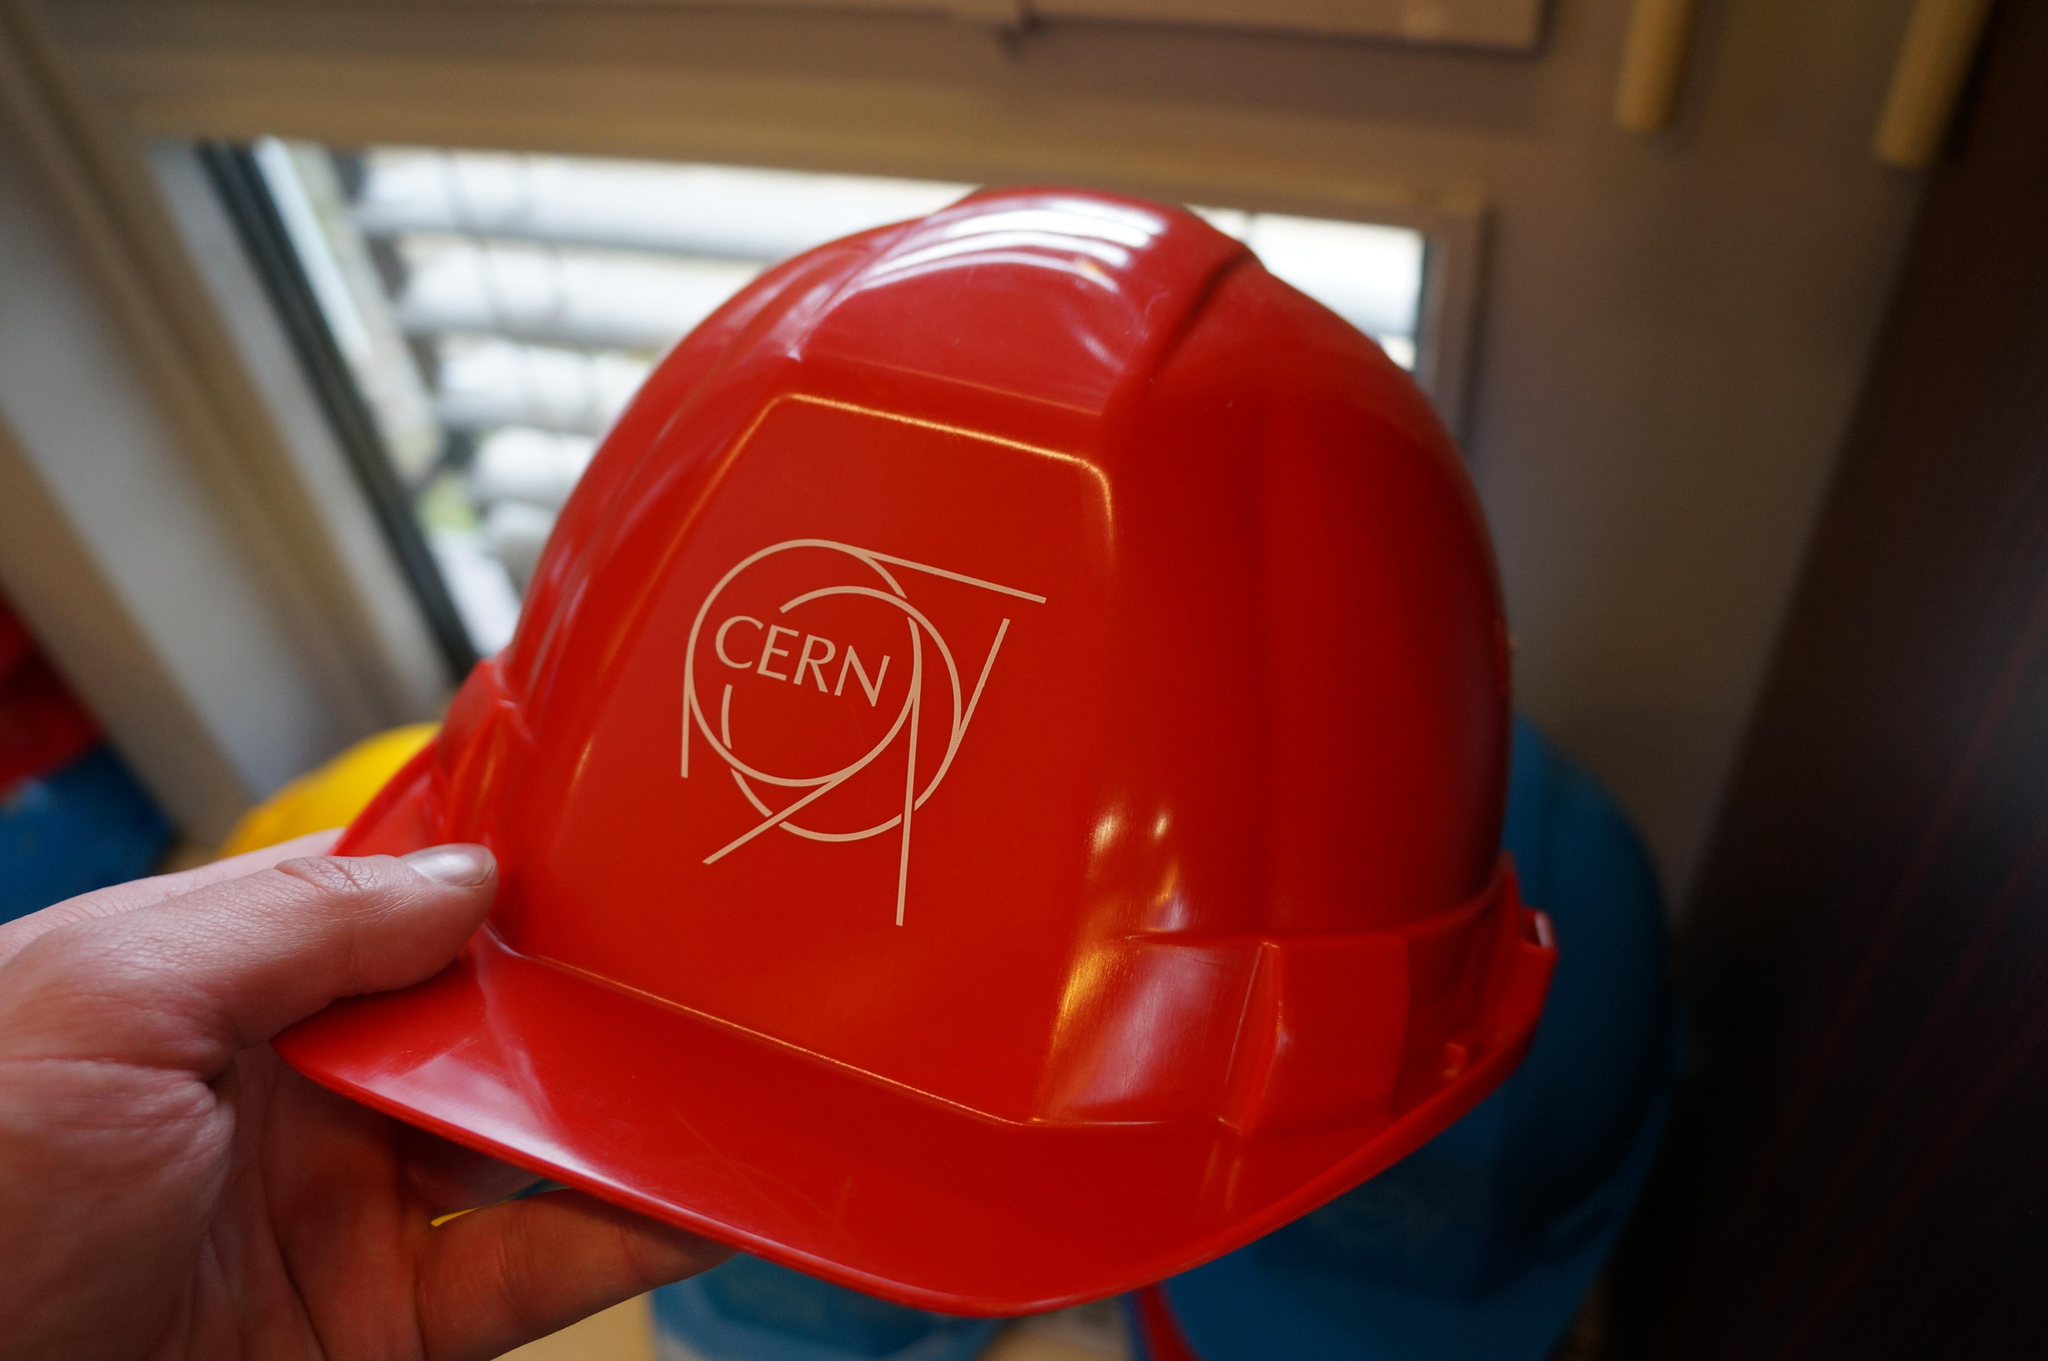What is the main subject of the image? There is a person in the image. What is the person holding in the image? The person is holding a red color hat. Can you describe the background of the image? The background of the image is blurred. What type of voice can be heard coming from the person in the image? There is no indication of any sound or voice in the image, as it is a still photograph. What type of test is being conducted in the image? There is no indication of any test being conducted in the image. 